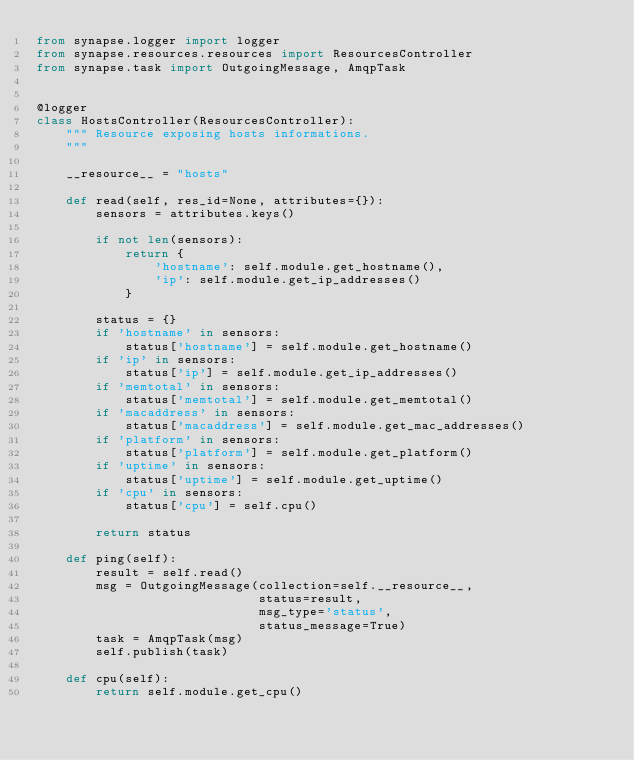Convert code to text. <code><loc_0><loc_0><loc_500><loc_500><_Python_>from synapse.logger import logger
from synapse.resources.resources import ResourcesController
from synapse.task import OutgoingMessage, AmqpTask


@logger
class HostsController(ResourcesController):
    """ Resource exposing hosts informations.
    """

    __resource__ = "hosts"

    def read(self, res_id=None, attributes={}):
        sensors = attributes.keys()

        if not len(sensors):
            return {
                'hostname': self.module.get_hostname(),
                'ip': self.module.get_ip_addresses()
            }

        status = {}
        if 'hostname' in sensors:
            status['hostname'] = self.module.get_hostname()
        if 'ip' in sensors:
            status['ip'] = self.module.get_ip_addresses()
        if 'memtotal' in sensors:
            status['memtotal'] = self.module.get_memtotal()
        if 'macaddress' in sensors:
            status['macaddress'] = self.module.get_mac_addresses()
        if 'platform' in sensors:
            status['platform'] = self.module.get_platform()
        if 'uptime' in sensors:
            status['uptime'] = self.module.get_uptime()
        if 'cpu' in sensors:
            status['cpu'] = self.cpu()

        return status

    def ping(self):
        result = self.read()
        msg = OutgoingMessage(collection=self.__resource__,
                              status=result,
                              msg_type='status',
                              status_message=True)
        task = AmqpTask(msg)
        self.publish(task)

    def cpu(self):
        return self.module.get_cpu()

</code> 